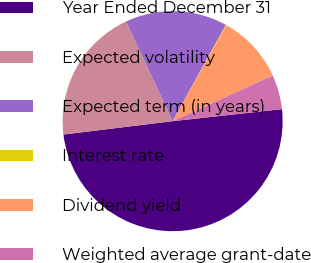Convert chart. <chart><loc_0><loc_0><loc_500><loc_500><pie_chart><fcel>Year Ended December 31<fcel>Expected volatility<fcel>Expected term (in years)<fcel>Interest rate<fcel>Dividend yield<fcel>Weighted average grant-date<nl><fcel>49.81%<fcel>19.98%<fcel>15.01%<fcel>0.1%<fcel>10.04%<fcel>5.07%<nl></chart> 